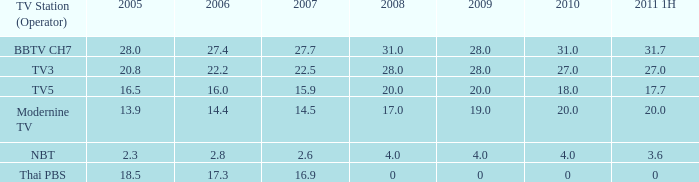7? 0.0. 